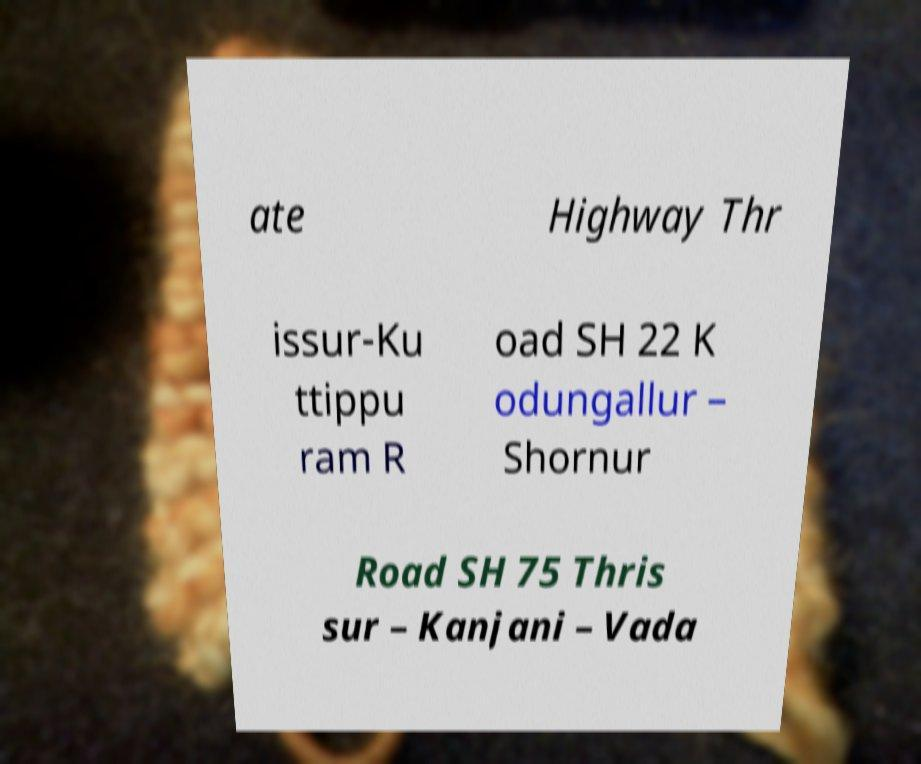For documentation purposes, I need the text within this image transcribed. Could you provide that? ate Highway Thr issur-Ku ttippu ram R oad SH 22 K odungallur – Shornur Road SH 75 Thris sur – Kanjani – Vada 